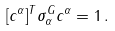<formula> <loc_0><loc_0><loc_500><loc_500>[ { c } ^ { \alpha } ] ^ { T } \sigma _ { \alpha } ^ { G } { c } ^ { \alpha } = 1 \, .</formula> 